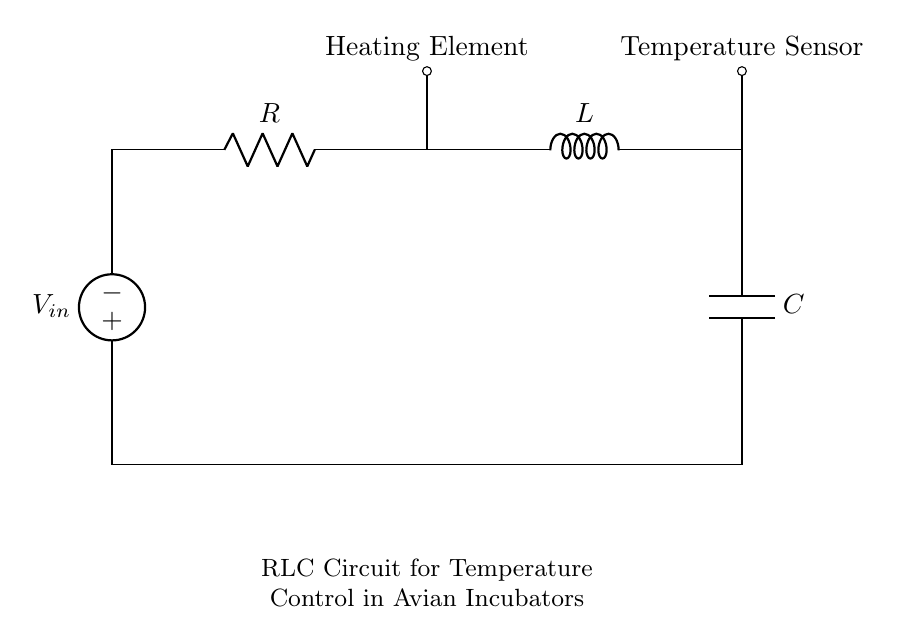What is the input voltage of this circuit? The input voltage is represented by the voltage source labeled as V_in. It supplies electrical energy to the circuit. Based on the visual information in the circuit diagram, the specific value is not provided, but it's identified as the point where the circuit receives power.
Answer: V_in What component is used to provide resistance in this circuit? The component that provides resistance is labeled as R in the diagram. It impedes the flow of current within the circuit. Thus, it plays an essential role in controlling the current and dropping voltage across it.
Answer: R What two additional components are present alongside the resistor? The two additional components are an inductor labeled as L and a capacitor labeled as C. These components work together with the resistor to form an RLC circuit. The inductor stores energy in a magnetic field, while the capacitor stores energy in an electric field.
Answer: L, C What is the function of the heating element in this circuit? The heating element, indicated in the circuit diagram, functions to generate heat. It converts electrical energy into thermal energy, which is crucial for maintaining the temperature inside avian incubators. The heating element's operation is directly influenced by the control provided by the RLC circuit.
Answer: Heating Element Which component is used to sense temperature? The temperature sensor is the component labeled at the output on the right side of the circuit diagram. Its purpose is to detect the temperature and provide feedback to the control system, ensuring that the incubator maintains optimal conditions for the avian species.
Answer: Temperature Sensor How do the components interact to control temperature? The interaction among the resistor, inductor, and capacitor allows for a tuning effect in the circuit that regulates the temperature. The resistor limits current, the inductor smooths the variations from the heating element, and the capacitor absorbs excess current, stabilizing the entire system. This combination enables precise temperature control in the incubator.
Answer: They tune and stabilize temperature control 